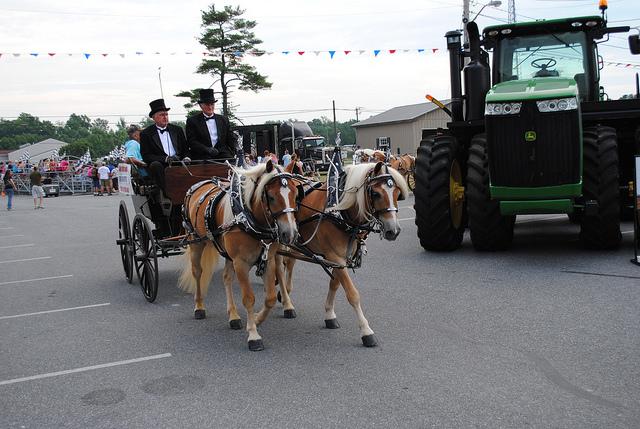What are the animals?
Quick response, please. Horses. How many horses are there?
Give a very brief answer. 2. What color is the wagon the horses are pulling?
Short answer required. Brown. How many top hats are there?
Quick response, please. 2. What kind of tractor is shown?
Keep it brief. John deere. 